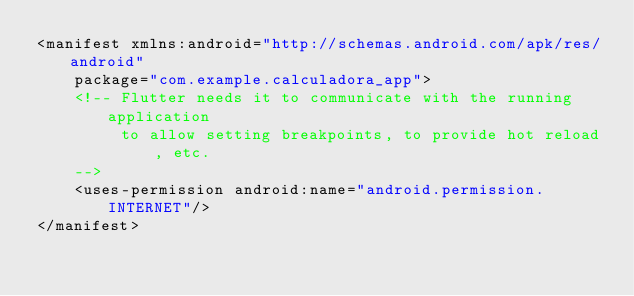Convert code to text. <code><loc_0><loc_0><loc_500><loc_500><_XML_><manifest xmlns:android="http://schemas.android.com/apk/res/android"
    package="com.example.calculadora_app">
    <!-- Flutter needs it to communicate with the running application
         to allow setting breakpoints, to provide hot reload, etc.
    -->
    <uses-permission android:name="android.permission.INTERNET"/>
</manifest>
</code> 